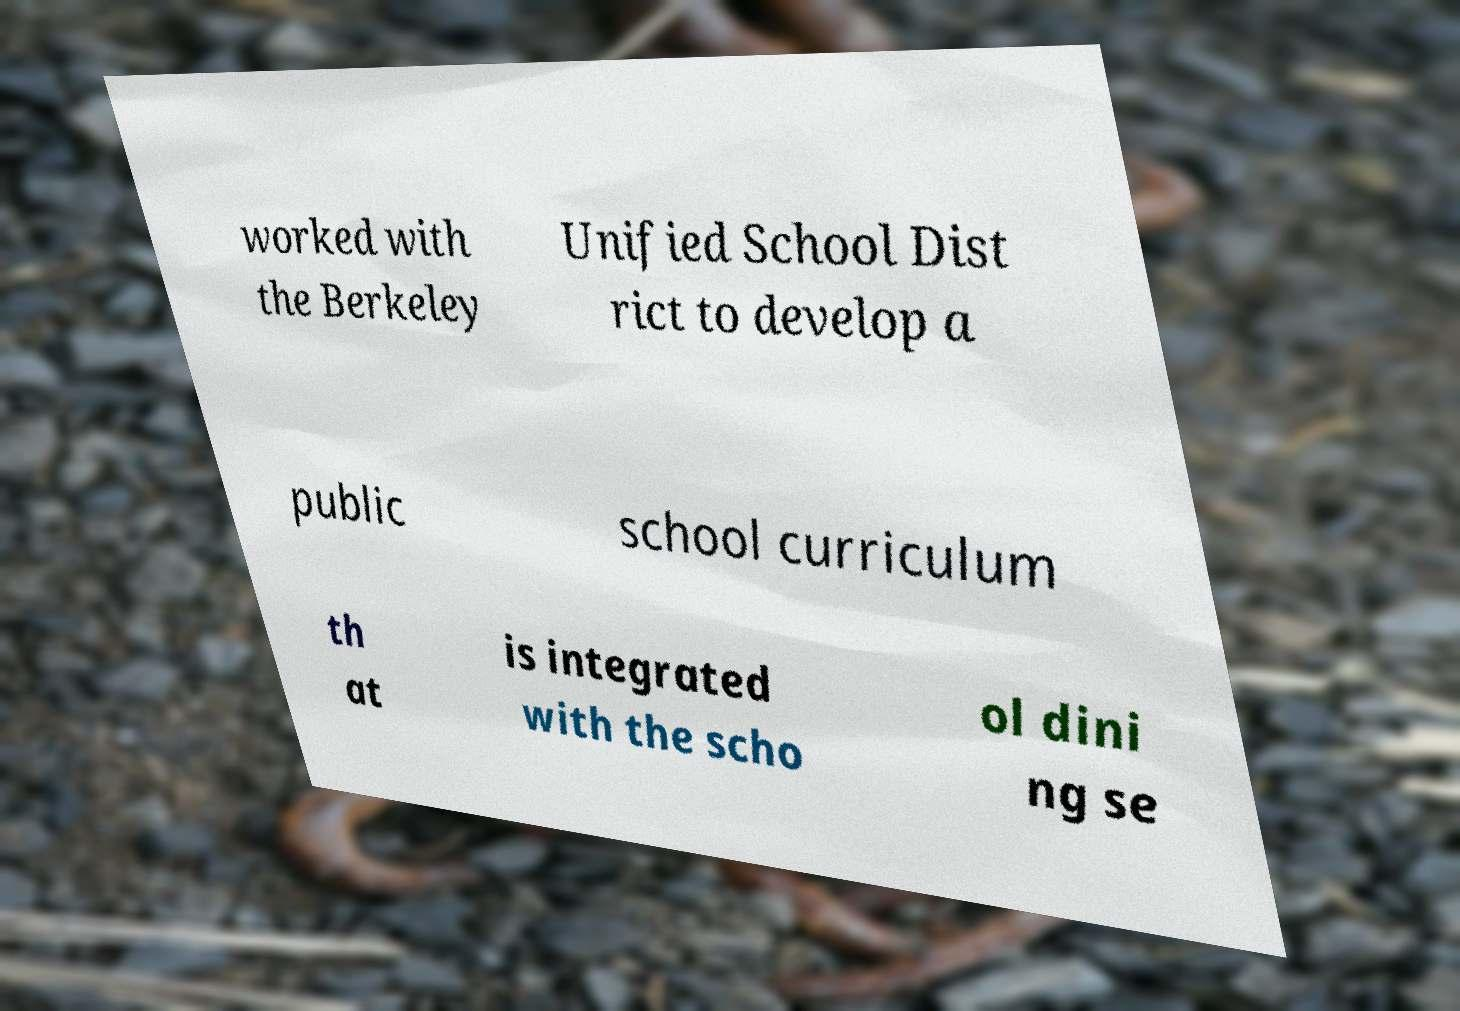There's text embedded in this image that I need extracted. Can you transcribe it verbatim? worked with the Berkeley Unified School Dist rict to develop a public school curriculum th at is integrated with the scho ol dini ng se 